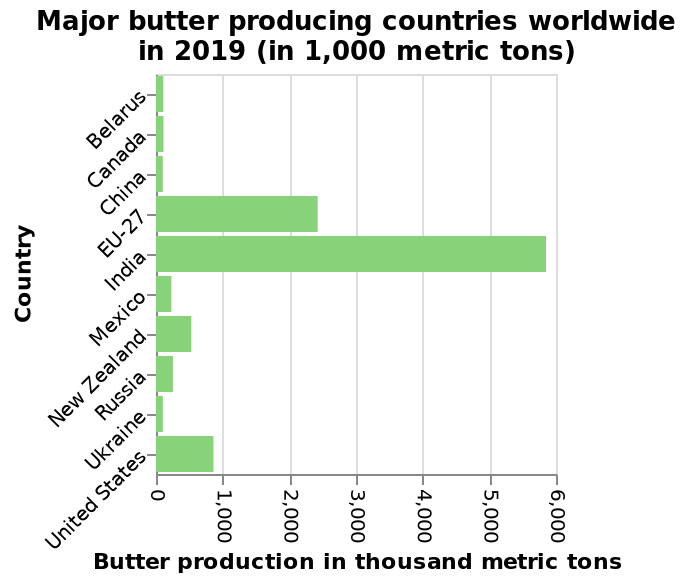<image>
Which region or group of countries produced the second-highest amount of butter in 2019?  EU 27 produced the second-highest amount of butter in 2019. What is the title of the bar graph? The title of the bar graph is "Major butter producing countries worldwide in 2019 (in 1,000 metric tons)." Which country produced the most butter in 2019?  India produced the most butter in 2019. 